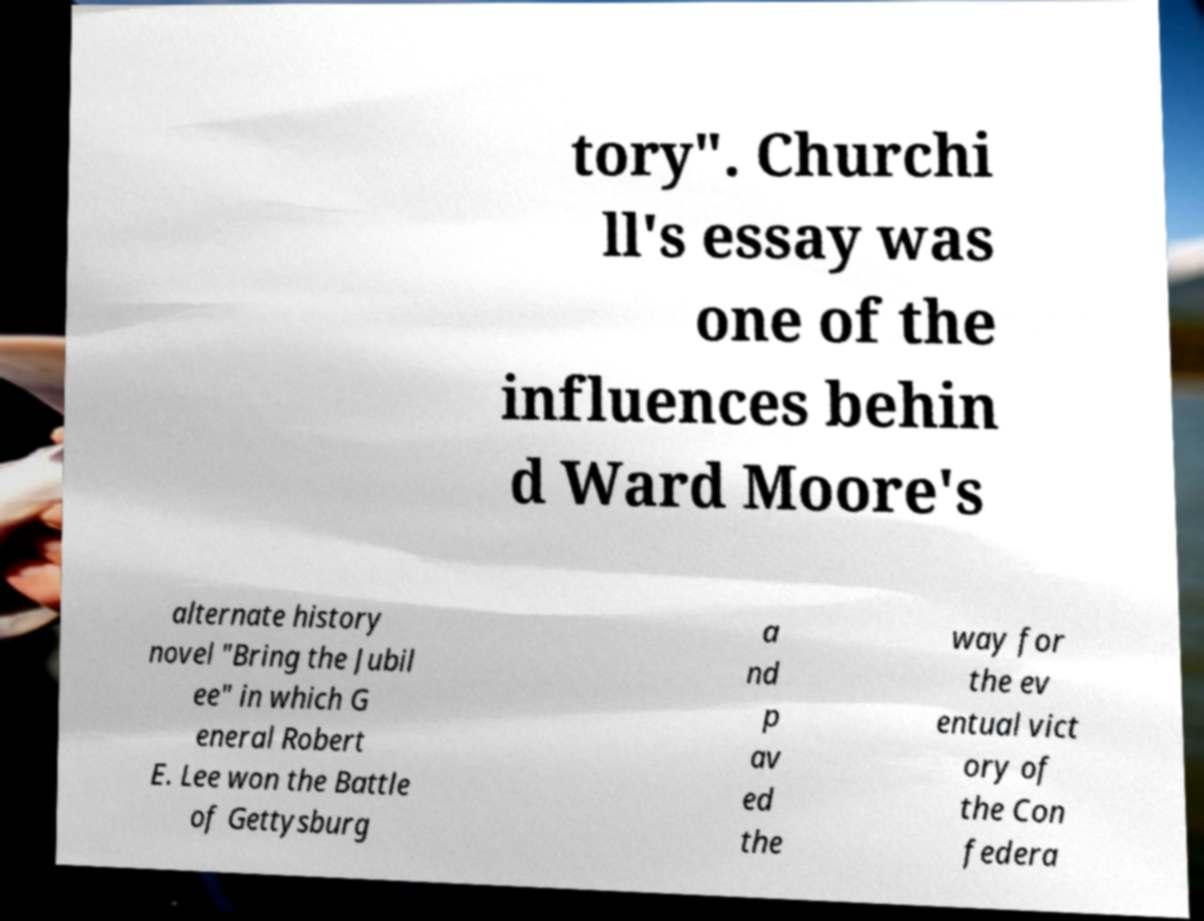There's text embedded in this image that I need extracted. Can you transcribe it verbatim? tory". Churchi ll's essay was one of the influences behin d Ward Moore's alternate history novel "Bring the Jubil ee" in which G eneral Robert E. Lee won the Battle of Gettysburg a nd p av ed the way for the ev entual vict ory of the Con federa 